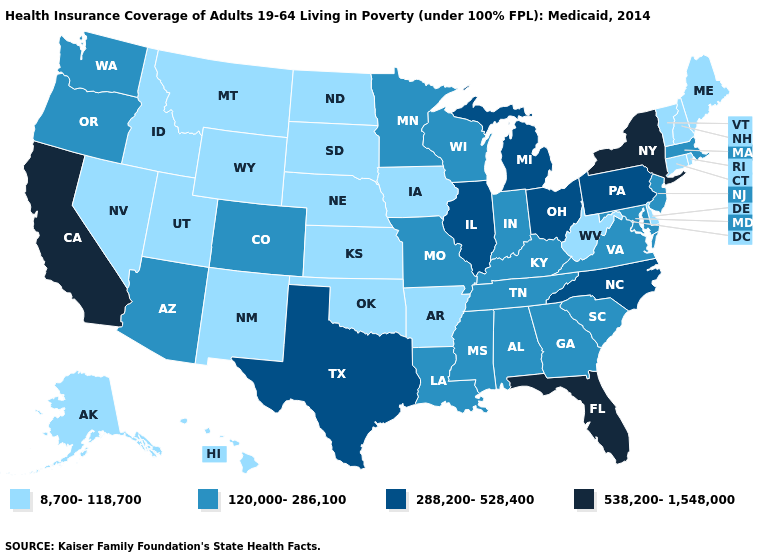Does Arkansas have a lower value than Wyoming?
Write a very short answer. No. Does Nevada have the lowest value in the West?
Short answer required. Yes. What is the lowest value in states that border Kentucky?
Concise answer only. 8,700-118,700. Which states have the highest value in the USA?
Give a very brief answer. California, Florida, New York. Which states have the lowest value in the USA?
Keep it brief. Alaska, Arkansas, Connecticut, Delaware, Hawaii, Idaho, Iowa, Kansas, Maine, Montana, Nebraska, Nevada, New Hampshire, New Mexico, North Dakota, Oklahoma, Rhode Island, South Dakota, Utah, Vermont, West Virginia, Wyoming. What is the value of Rhode Island?
Quick response, please. 8,700-118,700. Name the states that have a value in the range 8,700-118,700?
Be succinct. Alaska, Arkansas, Connecticut, Delaware, Hawaii, Idaho, Iowa, Kansas, Maine, Montana, Nebraska, Nevada, New Hampshire, New Mexico, North Dakota, Oklahoma, Rhode Island, South Dakota, Utah, Vermont, West Virginia, Wyoming. Which states have the lowest value in the USA?
Give a very brief answer. Alaska, Arkansas, Connecticut, Delaware, Hawaii, Idaho, Iowa, Kansas, Maine, Montana, Nebraska, Nevada, New Hampshire, New Mexico, North Dakota, Oklahoma, Rhode Island, South Dakota, Utah, Vermont, West Virginia, Wyoming. Does New Mexico have the highest value in the USA?
Keep it brief. No. Which states have the highest value in the USA?
Be succinct. California, Florida, New York. Among the states that border Nevada , which have the lowest value?
Keep it brief. Idaho, Utah. Among the states that border Illinois , which have the highest value?
Be succinct. Indiana, Kentucky, Missouri, Wisconsin. Does Arizona have a higher value than New Mexico?
Concise answer only. Yes. Name the states that have a value in the range 120,000-286,100?
Keep it brief. Alabama, Arizona, Colorado, Georgia, Indiana, Kentucky, Louisiana, Maryland, Massachusetts, Minnesota, Mississippi, Missouri, New Jersey, Oregon, South Carolina, Tennessee, Virginia, Washington, Wisconsin. 